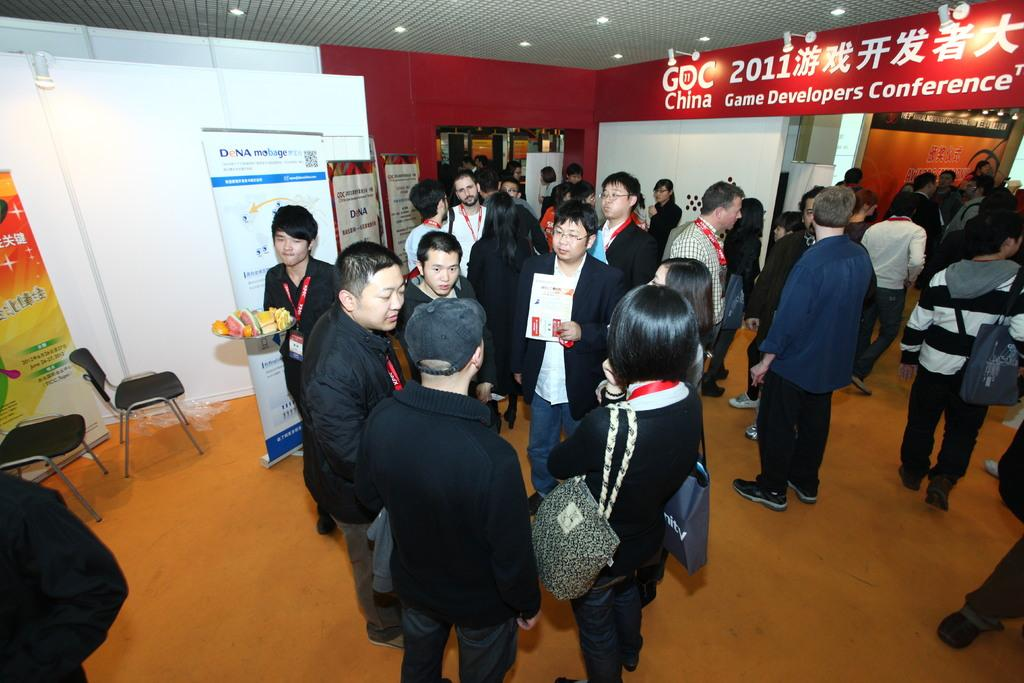What are the people in the image doing? There is a group of people on the floor in the image. What type of furniture can be seen in the image? There are chairs in the image. What decorative elements are present in the image? There are banners and boards in the image. What part of the room is visible in the image? This is the ceiling in the image. What type of lighting is present in the image? There are lights in the image. What architectural feature can be seen in the image? There is a wall in the image. How many clovers are growing on the wall in the image? There are no clovers present in the image; it features a wall without any plants. What type of branch can be seen hanging from the ceiling in the image? There is no branch present in the image; the ceiling only contains lights. 